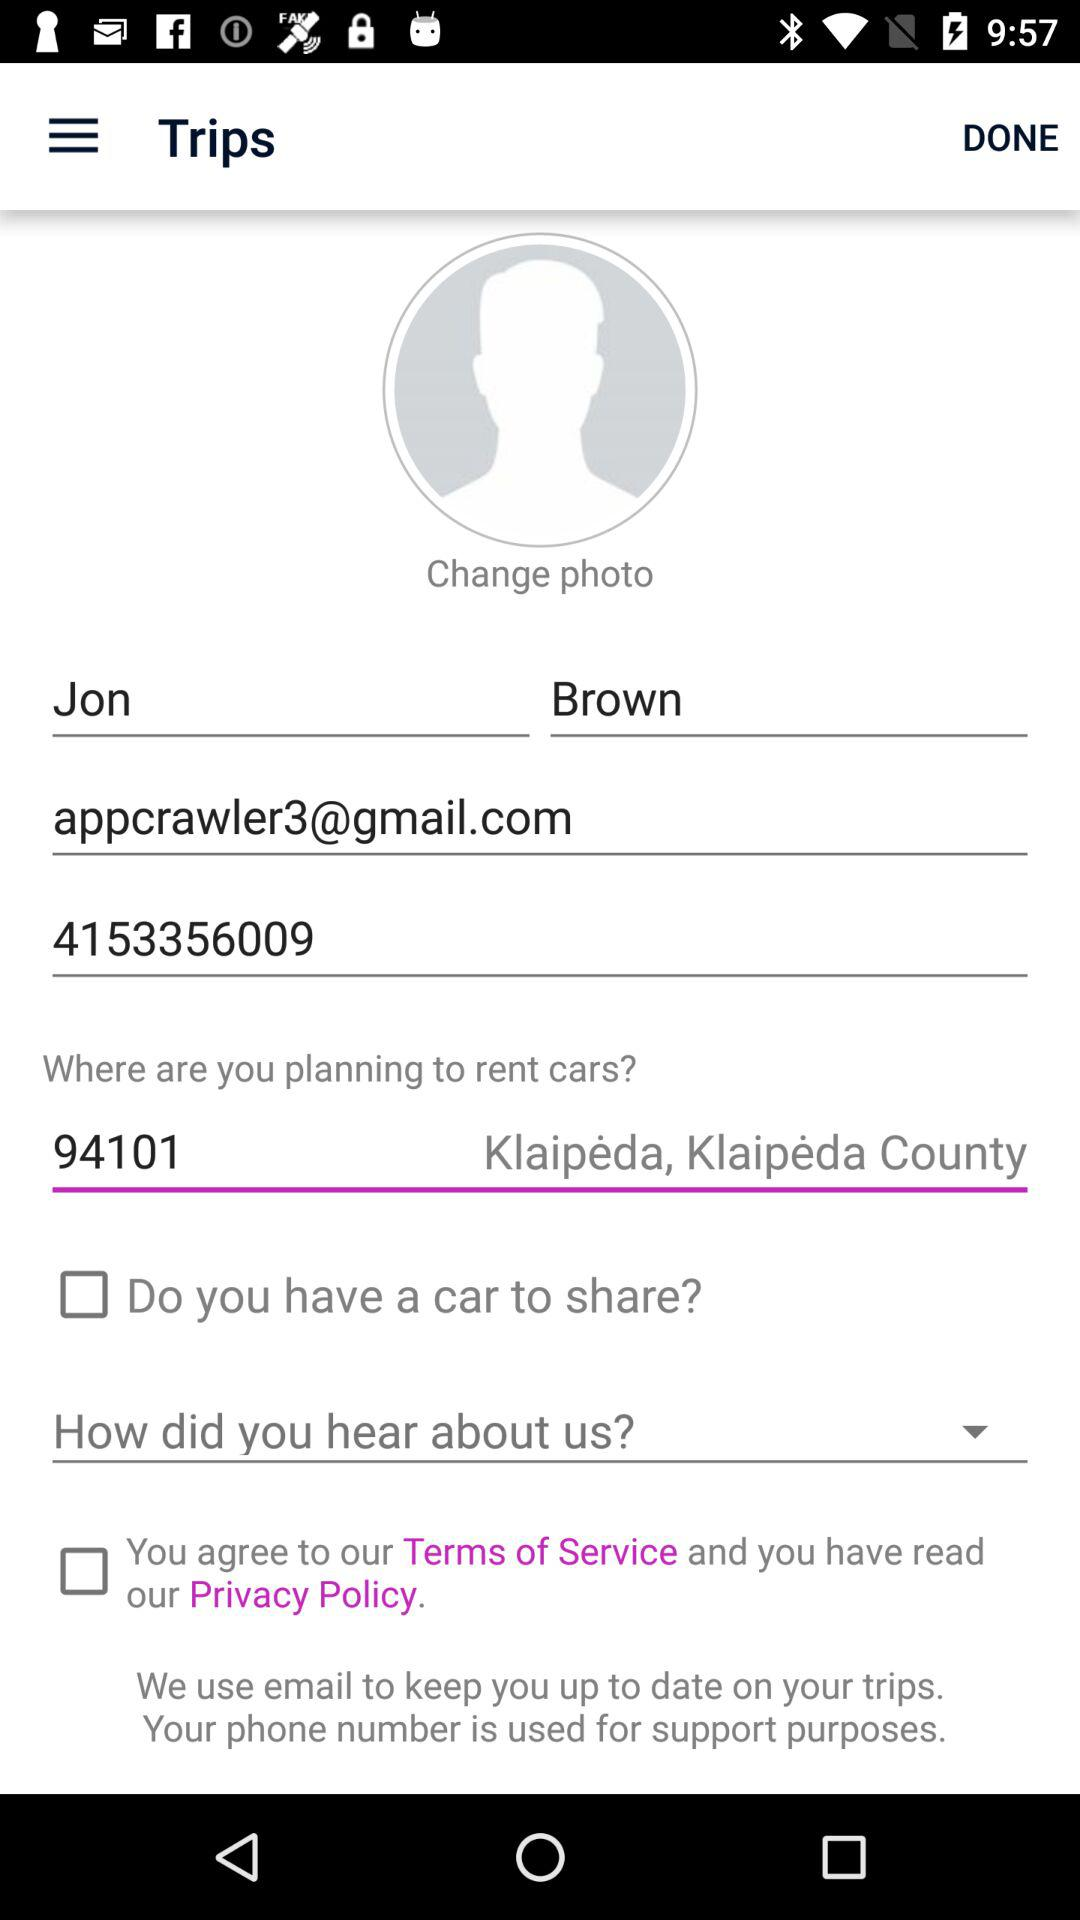What is the name of the county where I can rent a car? The name of the county is Klaipėda County. 